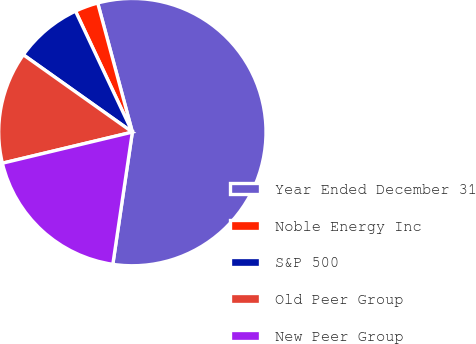<chart> <loc_0><loc_0><loc_500><loc_500><pie_chart><fcel>Year Ended December 31<fcel>Noble Energy Inc<fcel>S&P 500<fcel>Old Peer Group<fcel>New Peer Group<nl><fcel>56.52%<fcel>2.82%<fcel>8.19%<fcel>13.56%<fcel>18.93%<nl></chart> 